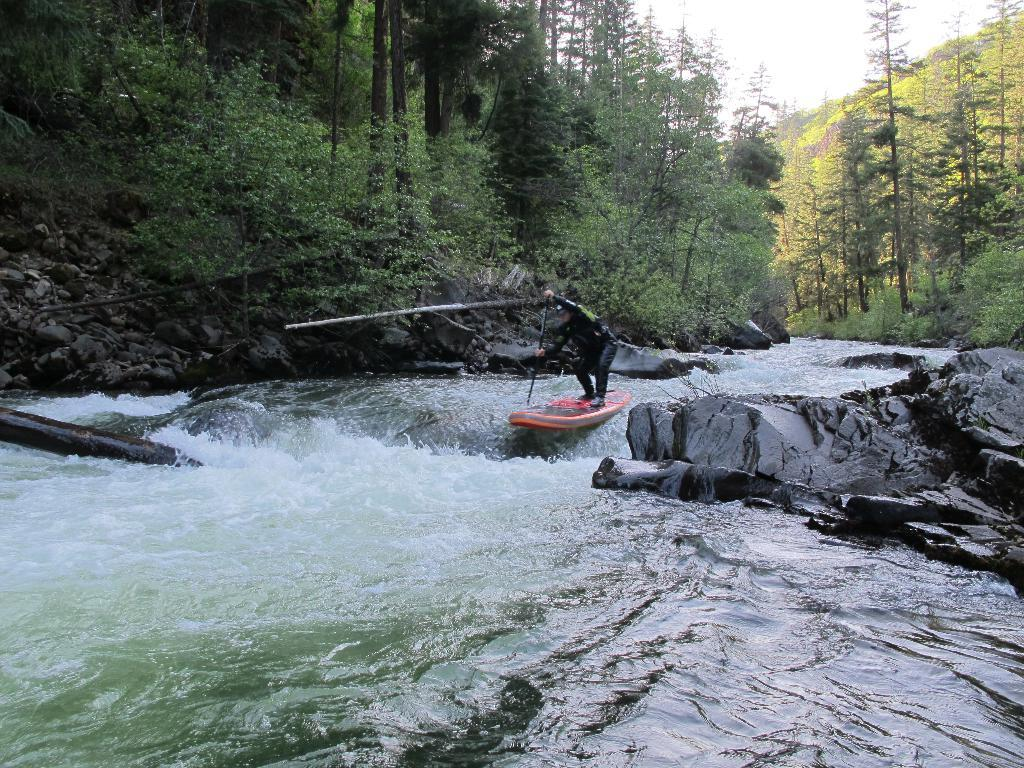What is the main subject of the image? There is a person in the image. What is the person doing in the image? The person is standing on a surfboard. What is the person holding in the image? The person is holding a stick. What type of environment is visible in the image? There is water visible in the image, and there are stones present. What can be seen in the background of the image? There are trees and the sky visible in the background of the image. What type of bone can be seen sticking out of the person's sock in the image? There is no bone or sock present in the image; the person is wearing shoes and standing on a surfboard. 